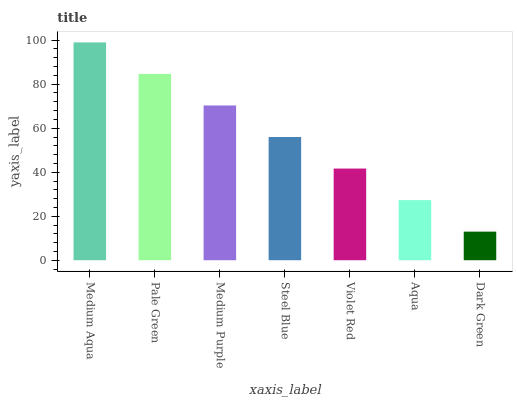Is Dark Green the minimum?
Answer yes or no. Yes. Is Medium Aqua the maximum?
Answer yes or no. Yes. Is Pale Green the minimum?
Answer yes or no. No. Is Pale Green the maximum?
Answer yes or no. No. Is Medium Aqua greater than Pale Green?
Answer yes or no. Yes. Is Pale Green less than Medium Aqua?
Answer yes or no. Yes. Is Pale Green greater than Medium Aqua?
Answer yes or no. No. Is Medium Aqua less than Pale Green?
Answer yes or no. No. Is Steel Blue the high median?
Answer yes or no. Yes. Is Steel Blue the low median?
Answer yes or no. Yes. Is Aqua the high median?
Answer yes or no. No. Is Dark Green the low median?
Answer yes or no. No. 